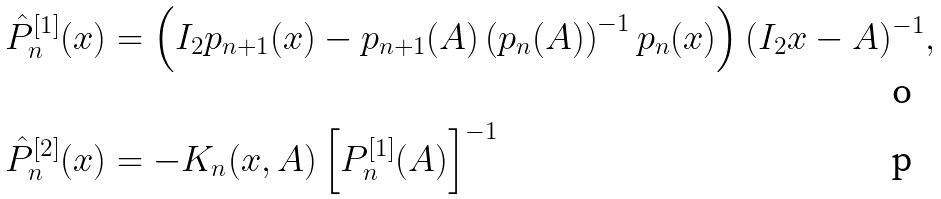Convert formula to latex. <formula><loc_0><loc_0><loc_500><loc_500>\hat { P } ^ { [ 1 ] } _ { n } ( x ) & = \left ( I _ { 2 } p _ { n + 1 } ( x ) - p _ { n + 1 } ( A ) \left ( p _ { n } ( A ) \right ) ^ { - 1 } p _ { n } ( x ) \right ) ( I _ { 2 } x - A ) ^ { - 1 } , \\ \hat { P } ^ { [ 2 ] } _ { n } ( x ) & = - K _ { n } ( x , A ) \left [ P _ { n } ^ { [ 1 ] } ( A ) \right ] ^ { - 1 }</formula> 